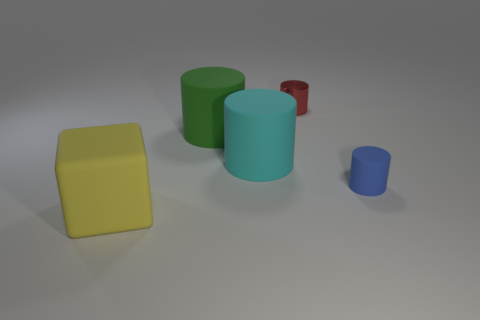There is a red metallic object that is on the right side of the big cyan rubber thing; is its shape the same as the green object?
Keep it short and to the point. Yes. How many other objects are the same shape as the green rubber object?
Give a very brief answer. 3. The large object that is right of the large green thing has what shape?
Provide a succinct answer. Cylinder. Are there any other small cylinders made of the same material as the cyan cylinder?
Your answer should be compact. Yes. What is the size of the yellow object?
Your response must be concise. Large. Is there a large yellow rubber object that is to the left of the small cylinder in front of the tiny cylinder on the left side of the small blue rubber object?
Make the answer very short. Yes. There is a cube; what number of rubber blocks are in front of it?
Provide a short and direct response. 0. What number of objects are either large rubber things that are right of the yellow cube or large things in front of the tiny blue thing?
Your response must be concise. 3. Is the number of green rubber cylinders greater than the number of tiny purple metal blocks?
Your answer should be very brief. Yes. What color is the small object behind the tiny matte object?
Make the answer very short. Red. 